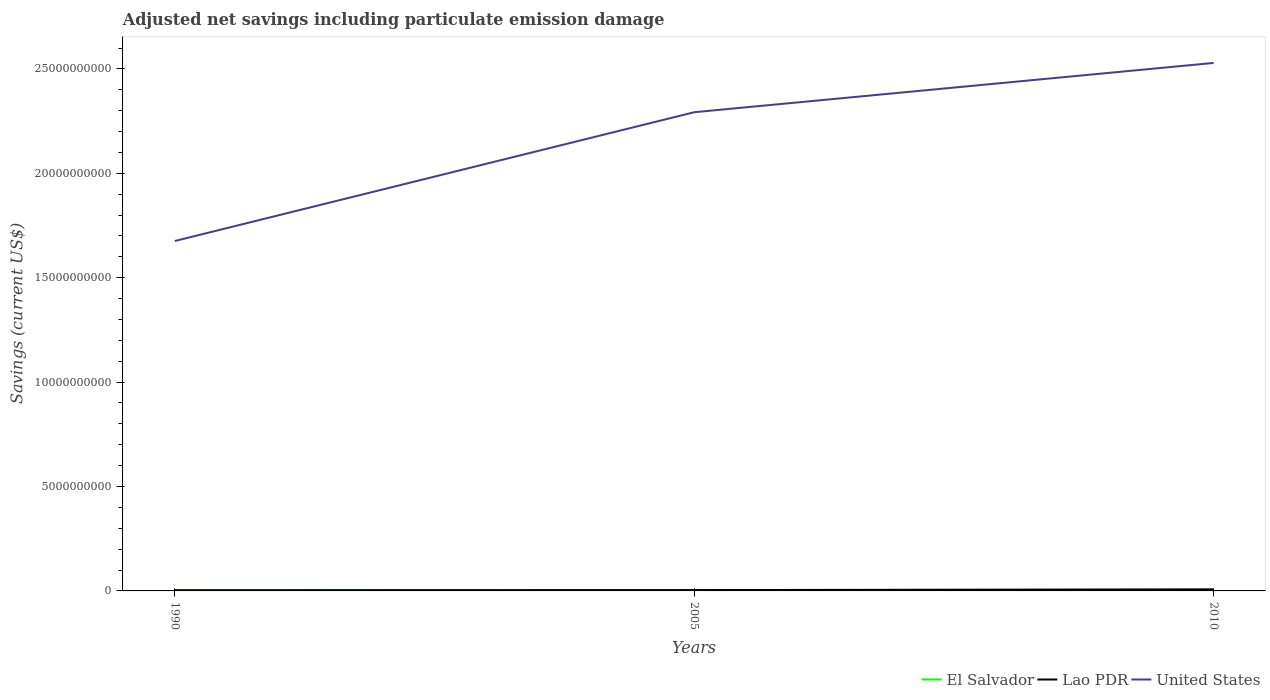Is the number of lines equal to the number of legend labels?
Your response must be concise. Yes. Across all years, what is the maximum net savings in Lao PDR?
Offer a very short reply. 3.12e+07. In which year was the net savings in Lao PDR maximum?
Keep it short and to the point. 1990. What is the total net savings in United States in the graph?
Your response must be concise. -6.17e+09. What is the difference between the highest and the second highest net savings in Lao PDR?
Ensure brevity in your answer.  4.40e+07. What is the difference between the highest and the lowest net savings in Lao PDR?
Your answer should be very brief. 1. How many years are there in the graph?
Give a very brief answer. 3. What is the difference between two consecutive major ticks on the Y-axis?
Your answer should be very brief. 5.00e+09. Are the values on the major ticks of Y-axis written in scientific E-notation?
Your answer should be compact. No. Does the graph contain any zero values?
Your answer should be compact. No. Where does the legend appear in the graph?
Your response must be concise. Bottom right. How many legend labels are there?
Provide a succinct answer. 3. What is the title of the graph?
Your response must be concise. Adjusted net savings including particulate emission damage. What is the label or title of the X-axis?
Offer a very short reply. Years. What is the label or title of the Y-axis?
Make the answer very short. Savings (current US$). What is the Savings (current US$) of El Salvador in 1990?
Your response must be concise. 3.51e+07. What is the Savings (current US$) of Lao PDR in 1990?
Your answer should be very brief. 3.12e+07. What is the Savings (current US$) in United States in 1990?
Keep it short and to the point. 1.68e+1. What is the Savings (current US$) in El Salvador in 2005?
Make the answer very short. 4.15e+07. What is the Savings (current US$) of Lao PDR in 2005?
Provide a succinct answer. 3.97e+07. What is the Savings (current US$) in United States in 2005?
Your answer should be compact. 2.29e+1. What is the Savings (current US$) in El Salvador in 2010?
Keep it short and to the point. 3.96e+07. What is the Savings (current US$) in Lao PDR in 2010?
Offer a very short reply. 7.52e+07. What is the Savings (current US$) in United States in 2010?
Provide a succinct answer. 2.53e+1. Across all years, what is the maximum Savings (current US$) of El Salvador?
Your answer should be very brief. 4.15e+07. Across all years, what is the maximum Savings (current US$) in Lao PDR?
Provide a succinct answer. 7.52e+07. Across all years, what is the maximum Savings (current US$) in United States?
Ensure brevity in your answer.  2.53e+1. Across all years, what is the minimum Savings (current US$) in El Salvador?
Provide a short and direct response. 3.51e+07. Across all years, what is the minimum Savings (current US$) in Lao PDR?
Provide a succinct answer. 3.12e+07. Across all years, what is the minimum Savings (current US$) of United States?
Provide a succinct answer. 1.68e+1. What is the total Savings (current US$) in El Salvador in the graph?
Ensure brevity in your answer.  1.16e+08. What is the total Savings (current US$) in Lao PDR in the graph?
Provide a short and direct response. 1.46e+08. What is the total Savings (current US$) in United States in the graph?
Provide a short and direct response. 6.50e+1. What is the difference between the Savings (current US$) of El Salvador in 1990 and that in 2005?
Offer a very short reply. -6.34e+06. What is the difference between the Savings (current US$) in Lao PDR in 1990 and that in 2005?
Keep it short and to the point. -8.50e+06. What is the difference between the Savings (current US$) in United States in 1990 and that in 2005?
Your answer should be compact. -6.17e+09. What is the difference between the Savings (current US$) of El Salvador in 1990 and that in 2010?
Keep it short and to the point. -4.50e+06. What is the difference between the Savings (current US$) of Lao PDR in 1990 and that in 2010?
Provide a succinct answer. -4.40e+07. What is the difference between the Savings (current US$) of United States in 1990 and that in 2010?
Ensure brevity in your answer.  -8.53e+09. What is the difference between the Savings (current US$) of El Salvador in 2005 and that in 2010?
Provide a succinct answer. 1.84e+06. What is the difference between the Savings (current US$) of Lao PDR in 2005 and that in 2010?
Provide a short and direct response. -3.55e+07. What is the difference between the Savings (current US$) in United States in 2005 and that in 2010?
Your answer should be compact. -2.36e+09. What is the difference between the Savings (current US$) of El Salvador in 1990 and the Savings (current US$) of Lao PDR in 2005?
Offer a very short reply. -4.59e+06. What is the difference between the Savings (current US$) in El Salvador in 1990 and the Savings (current US$) in United States in 2005?
Your response must be concise. -2.29e+1. What is the difference between the Savings (current US$) of Lao PDR in 1990 and the Savings (current US$) of United States in 2005?
Give a very brief answer. -2.29e+1. What is the difference between the Savings (current US$) of El Salvador in 1990 and the Savings (current US$) of Lao PDR in 2010?
Offer a very short reply. -4.01e+07. What is the difference between the Savings (current US$) of El Salvador in 1990 and the Savings (current US$) of United States in 2010?
Give a very brief answer. -2.53e+1. What is the difference between the Savings (current US$) in Lao PDR in 1990 and the Savings (current US$) in United States in 2010?
Make the answer very short. -2.53e+1. What is the difference between the Savings (current US$) in El Salvador in 2005 and the Savings (current US$) in Lao PDR in 2010?
Keep it short and to the point. -3.37e+07. What is the difference between the Savings (current US$) in El Salvador in 2005 and the Savings (current US$) in United States in 2010?
Give a very brief answer. -2.52e+1. What is the difference between the Savings (current US$) in Lao PDR in 2005 and the Savings (current US$) in United States in 2010?
Your response must be concise. -2.52e+1. What is the average Savings (current US$) of El Salvador per year?
Make the answer very short. 3.87e+07. What is the average Savings (current US$) of Lao PDR per year?
Give a very brief answer. 4.87e+07. What is the average Savings (current US$) of United States per year?
Provide a succinct answer. 2.17e+1. In the year 1990, what is the difference between the Savings (current US$) in El Salvador and Savings (current US$) in Lao PDR?
Offer a terse response. 3.91e+06. In the year 1990, what is the difference between the Savings (current US$) of El Salvador and Savings (current US$) of United States?
Your answer should be very brief. -1.67e+1. In the year 1990, what is the difference between the Savings (current US$) in Lao PDR and Savings (current US$) in United States?
Give a very brief answer. -1.67e+1. In the year 2005, what is the difference between the Savings (current US$) in El Salvador and Savings (current US$) in Lao PDR?
Your answer should be compact. 1.74e+06. In the year 2005, what is the difference between the Savings (current US$) of El Salvador and Savings (current US$) of United States?
Ensure brevity in your answer.  -2.29e+1. In the year 2005, what is the difference between the Savings (current US$) of Lao PDR and Savings (current US$) of United States?
Keep it short and to the point. -2.29e+1. In the year 2010, what is the difference between the Savings (current US$) of El Salvador and Savings (current US$) of Lao PDR?
Your answer should be very brief. -3.56e+07. In the year 2010, what is the difference between the Savings (current US$) in El Salvador and Savings (current US$) in United States?
Offer a very short reply. -2.52e+1. In the year 2010, what is the difference between the Savings (current US$) of Lao PDR and Savings (current US$) of United States?
Ensure brevity in your answer.  -2.52e+1. What is the ratio of the Savings (current US$) in El Salvador in 1990 to that in 2005?
Offer a terse response. 0.85. What is the ratio of the Savings (current US$) of Lao PDR in 1990 to that in 2005?
Keep it short and to the point. 0.79. What is the ratio of the Savings (current US$) in United States in 1990 to that in 2005?
Provide a succinct answer. 0.73. What is the ratio of the Savings (current US$) of El Salvador in 1990 to that in 2010?
Make the answer very short. 0.89. What is the ratio of the Savings (current US$) in Lao PDR in 1990 to that in 2010?
Provide a short and direct response. 0.42. What is the ratio of the Savings (current US$) of United States in 1990 to that in 2010?
Offer a very short reply. 0.66. What is the ratio of the Savings (current US$) of El Salvador in 2005 to that in 2010?
Keep it short and to the point. 1.05. What is the ratio of the Savings (current US$) in Lao PDR in 2005 to that in 2010?
Your answer should be very brief. 0.53. What is the ratio of the Savings (current US$) in United States in 2005 to that in 2010?
Provide a short and direct response. 0.91. What is the difference between the highest and the second highest Savings (current US$) of El Salvador?
Offer a very short reply. 1.84e+06. What is the difference between the highest and the second highest Savings (current US$) of Lao PDR?
Offer a terse response. 3.55e+07. What is the difference between the highest and the second highest Savings (current US$) of United States?
Your answer should be very brief. 2.36e+09. What is the difference between the highest and the lowest Savings (current US$) in El Salvador?
Your answer should be compact. 6.34e+06. What is the difference between the highest and the lowest Savings (current US$) in Lao PDR?
Give a very brief answer. 4.40e+07. What is the difference between the highest and the lowest Savings (current US$) in United States?
Give a very brief answer. 8.53e+09. 